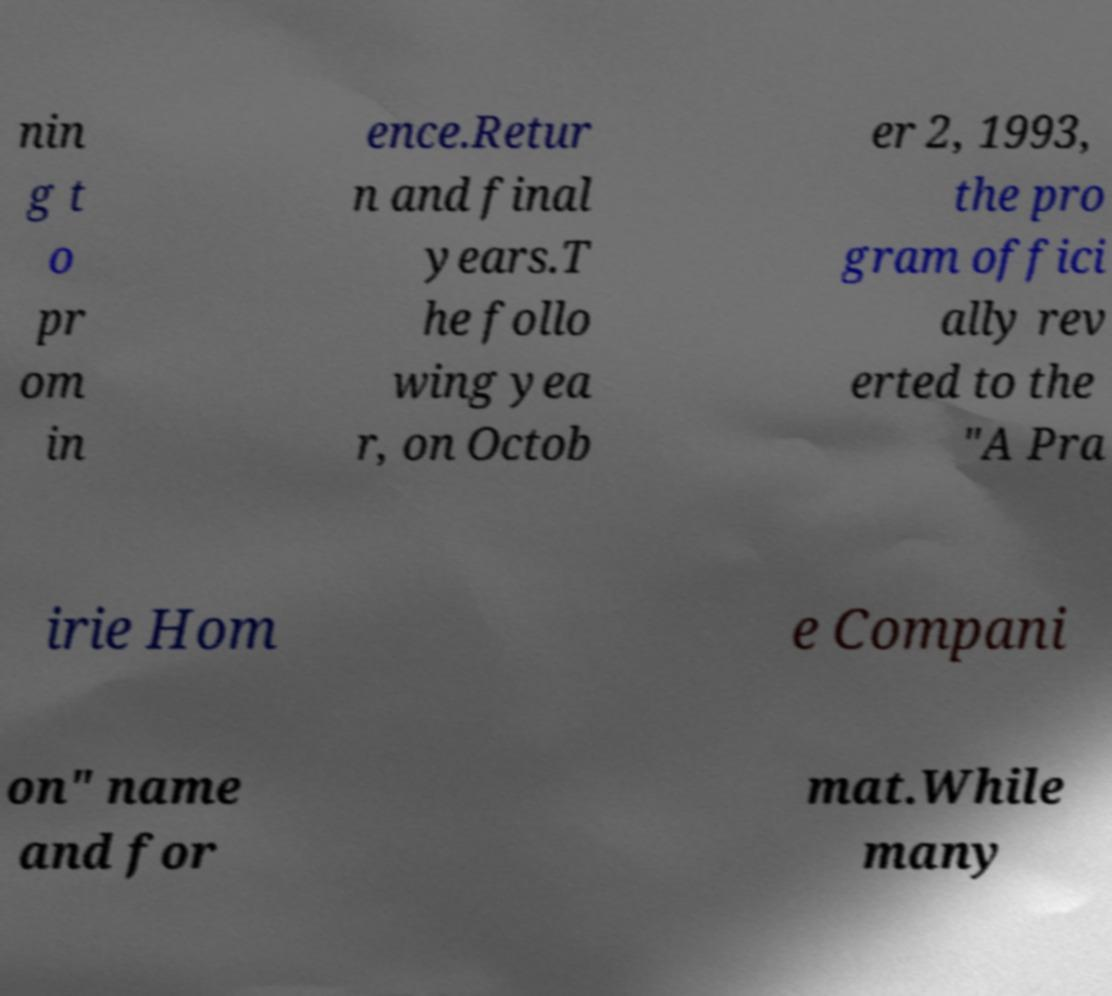Could you assist in decoding the text presented in this image and type it out clearly? nin g t o pr om in ence.Retur n and final years.T he follo wing yea r, on Octob er 2, 1993, the pro gram offici ally rev erted to the "A Pra irie Hom e Compani on" name and for mat.While many 